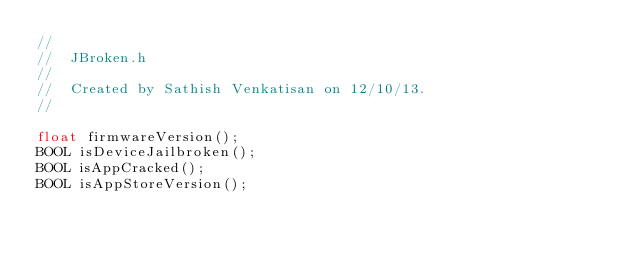Convert code to text. <code><loc_0><loc_0><loc_500><loc_500><_C_>//
//  JBroken.h
//
//  Created by Sathish Venkatisan on 12/10/13.
//

float firmwareVersion();
BOOL isDeviceJailbroken();
BOOL isAppCracked();
BOOL isAppStoreVersion();
</code> 